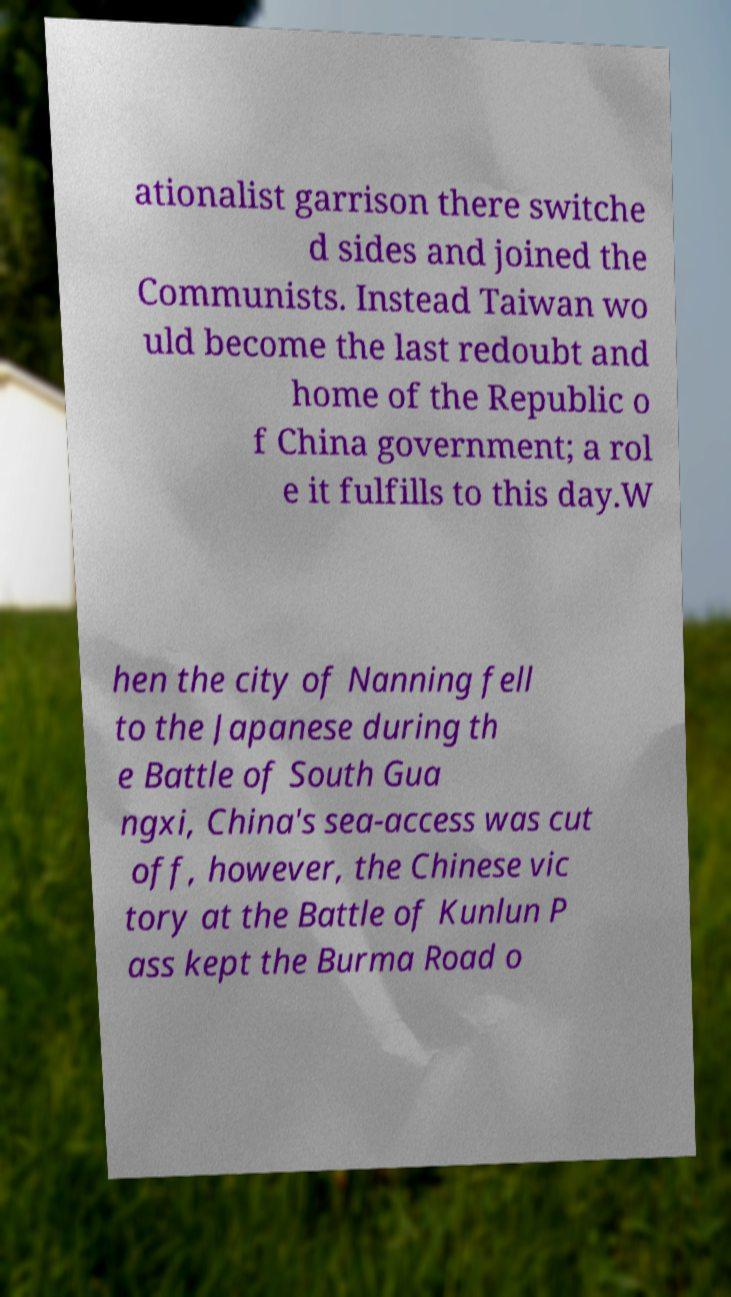Can you accurately transcribe the text from the provided image for me? ationalist garrison there switche d sides and joined the Communists. Instead Taiwan wo uld become the last redoubt and home of the Republic o f China government; a rol e it fulfills to this day.W hen the city of Nanning fell to the Japanese during th e Battle of South Gua ngxi, China's sea-access was cut off, however, the Chinese vic tory at the Battle of Kunlun P ass kept the Burma Road o 